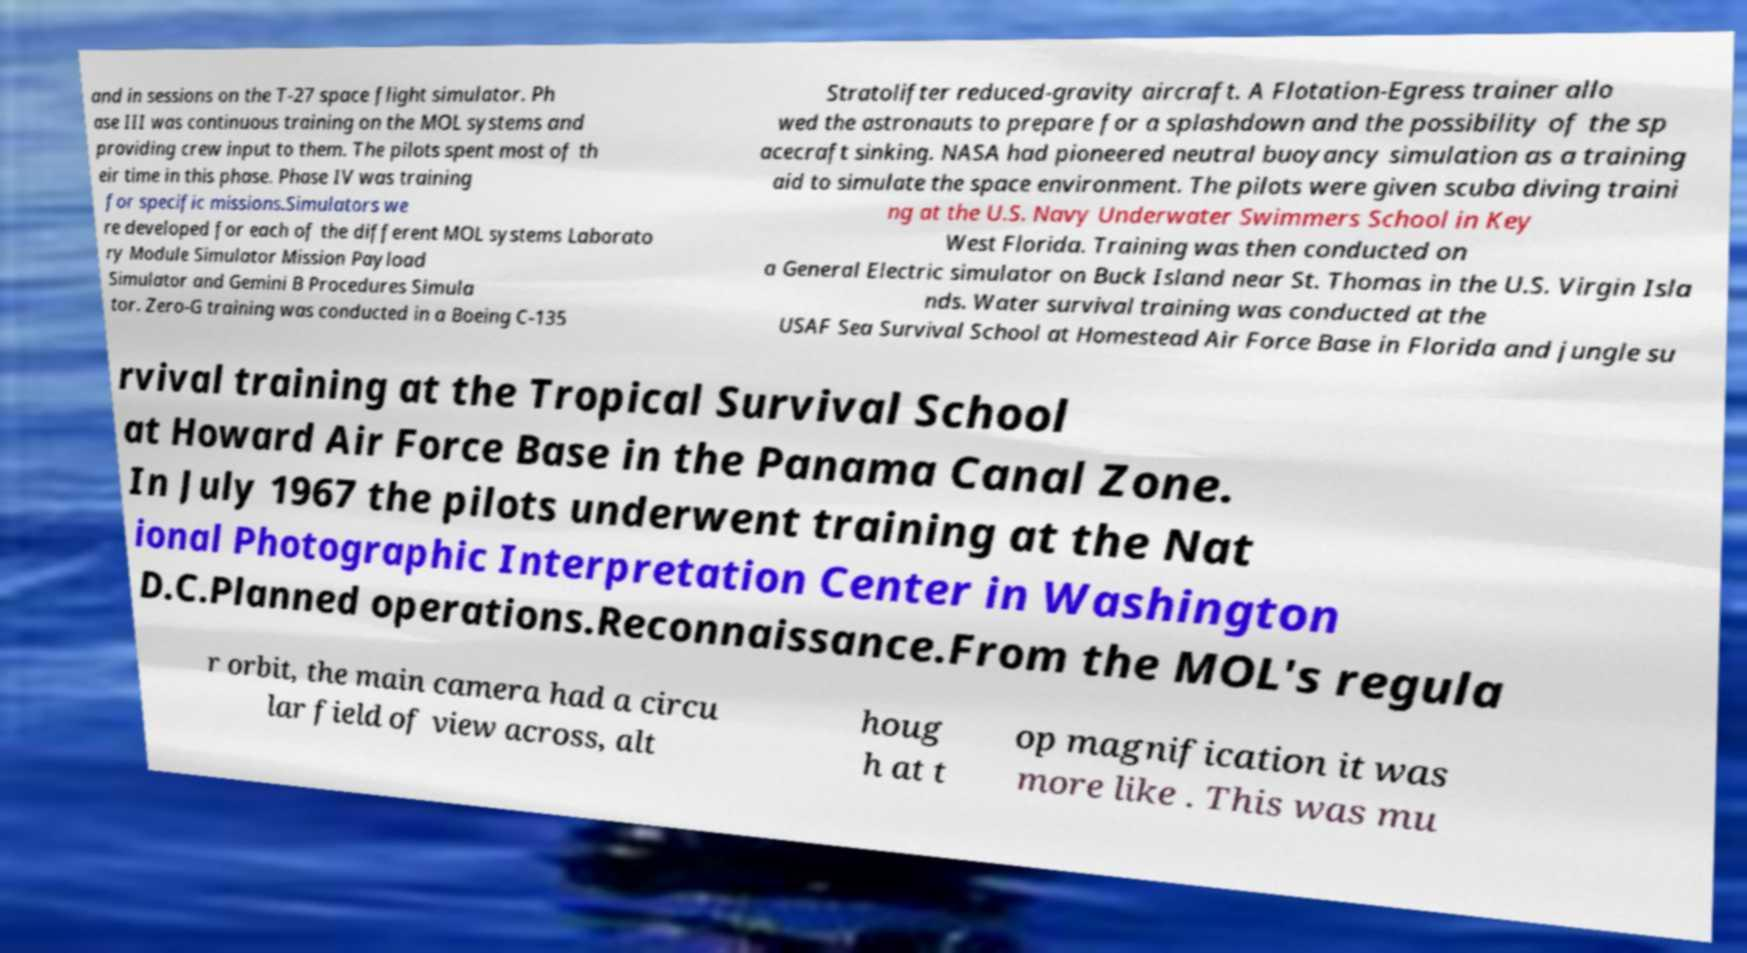Could you assist in decoding the text presented in this image and type it out clearly? and in sessions on the T-27 space flight simulator. Ph ase III was continuous training on the MOL systems and providing crew input to them. The pilots spent most of th eir time in this phase. Phase IV was training for specific missions.Simulators we re developed for each of the different MOL systems Laborato ry Module Simulator Mission Payload Simulator and Gemini B Procedures Simula tor. Zero-G training was conducted in a Boeing C-135 Stratolifter reduced-gravity aircraft. A Flotation-Egress trainer allo wed the astronauts to prepare for a splashdown and the possibility of the sp acecraft sinking. NASA had pioneered neutral buoyancy simulation as a training aid to simulate the space environment. The pilots were given scuba diving traini ng at the U.S. Navy Underwater Swimmers School in Key West Florida. Training was then conducted on a General Electric simulator on Buck Island near St. Thomas in the U.S. Virgin Isla nds. Water survival training was conducted at the USAF Sea Survival School at Homestead Air Force Base in Florida and jungle su rvival training at the Tropical Survival School at Howard Air Force Base in the Panama Canal Zone. In July 1967 the pilots underwent training at the Nat ional Photographic Interpretation Center in Washington D.C.Planned operations.Reconnaissance.From the MOL's regula r orbit, the main camera had a circu lar field of view across, alt houg h at t op magnification it was more like . This was mu 